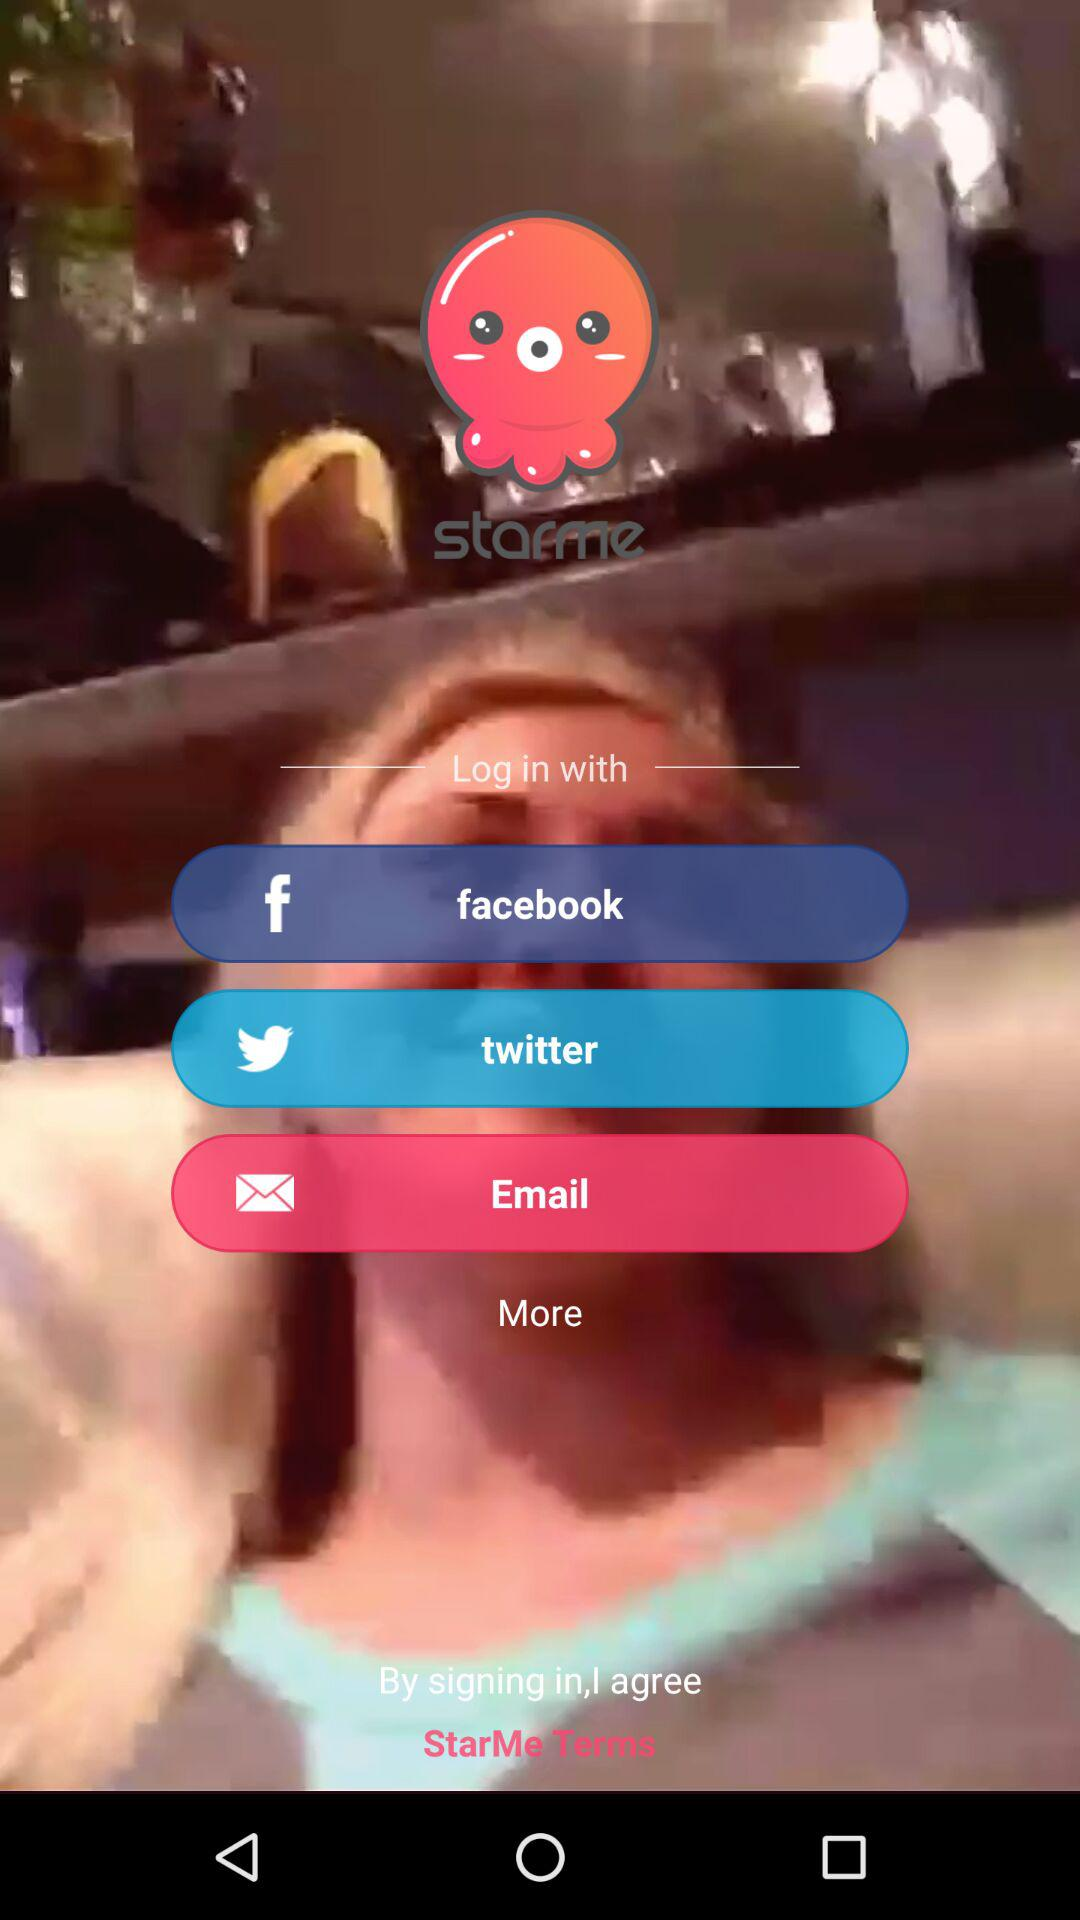What is the application name? The application name is "starme". 